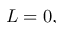Convert formula to latex. <formula><loc_0><loc_0><loc_500><loc_500>L = 0 ,</formula> 